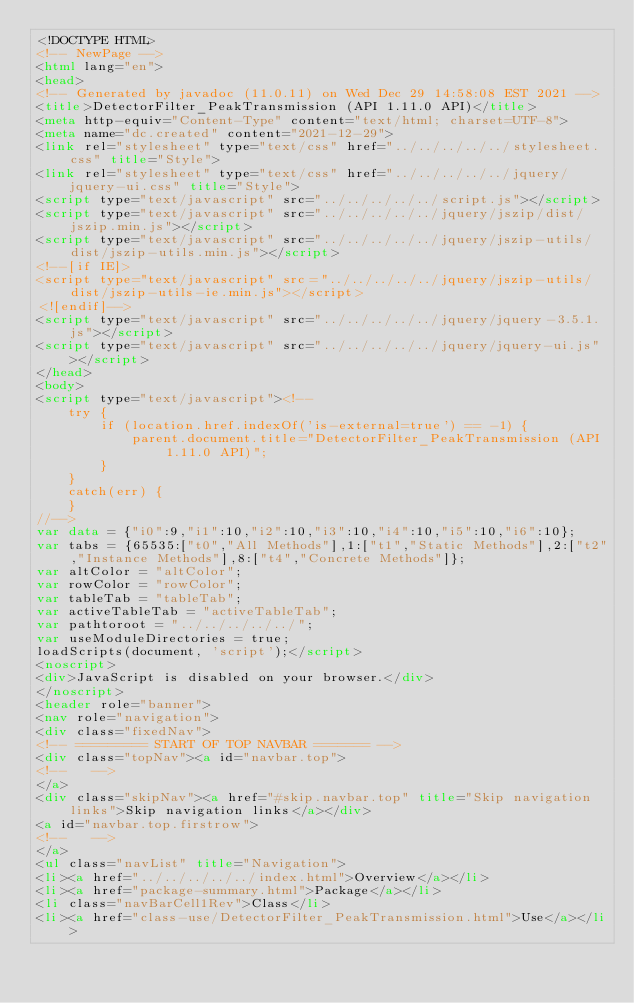<code> <loc_0><loc_0><loc_500><loc_500><_HTML_><!DOCTYPE HTML>
<!-- NewPage -->
<html lang="en">
<head>
<!-- Generated by javadoc (11.0.11) on Wed Dec 29 14:58:08 EST 2021 -->
<title>DetectorFilter_PeakTransmission (API 1.11.0 API)</title>
<meta http-equiv="Content-Type" content="text/html; charset=UTF-8">
<meta name="dc.created" content="2021-12-29">
<link rel="stylesheet" type="text/css" href="../../../../../stylesheet.css" title="Style">
<link rel="stylesheet" type="text/css" href="../../../../../jquery/jquery-ui.css" title="Style">
<script type="text/javascript" src="../../../../../script.js"></script>
<script type="text/javascript" src="../../../../../jquery/jszip/dist/jszip.min.js"></script>
<script type="text/javascript" src="../../../../../jquery/jszip-utils/dist/jszip-utils.min.js"></script>
<!--[if IE]>
<script type="text/javascript" src="../../../../../jquery/jszip-utils/dist/jszip-utils-ie.min.js"></script>
<![endif]-->
<script type="text/javascript" src="../../../../../jquery/jquery-3.5.1.js"></script>
<script type="text/javascript" src="../../../../../jquery/jquery-ui.js"></script>
</head>
<body>
<script type="text/javascript"><!--
    try {
        if (location.href.indexOf('is-external=true') == -1) {
            parent.document.title="DetectorFilter_PeakTransmission (API 1.11.0 API)";
        }
    }
    catch(err) {
    }
//-->
var data = {"i0":9,"i1":10,"i2":10,"i3":10,"i4":10,"i5":10,"i6":10};
var tabs = {65535:["t0","All Methods"],1:["t1","Static Methods"],2:["t2","Instance Methods"],8:["t4","Concrete Methods"]};
var altColor = "altColor";
var rowColor = "rowColor";
var tableTab = "tableTab";
var activeTableTab = "activeTableTab";
var pathtoroot = "../../../../../";
var useModuleDirectories = true;
loadScripts(document, 'script');</script>
<noscript>
<div>JavaScript is disabled on your browser.</div>
</noscript>
<header role="banner">
<nav role="navigation">
<div class="fixedNav">
<!-- ========= START OF TOP NAVBAR ======= -->
<div class="topNav"><a id="navbar.top">
<!--   -->
</a>
<div class="skipNav"><a href="#skip.navbar.top" title="Skip navigation links">Skip navigation links</a></div>
<a id="navbar.top.firstrow">
<!--   -->
</a>
<ul class="navList" title="Navigation">
<li><a href="../../../../../index.html">Overview</a></li>
<li><a href="package-summary.html">Package</a></li>
<li class="navBarCell1Rev">Class</li>
<li><a href="class-use/DetectorFilter_PeakTransmission.html">Use</a></li></code> 